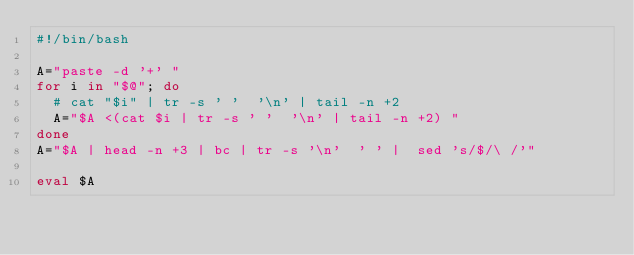Convert code to text. <code><loc_0><loc_0><loc_500><loc_500><_Bash_>#!/bin/bash

A="paste -d '+' "
for i in "$@"; do
  # cat "$i" | tr -s ' '  '\n' | tail -n +2
  A="$A <(cat $i | tr -s ' '  '\n' | tail -n +2) "
done
A="$A | head -n +3 | bc | tr -s '\n'  ' ' |  sed 's/$/\ /'"

eval $A

</code> 